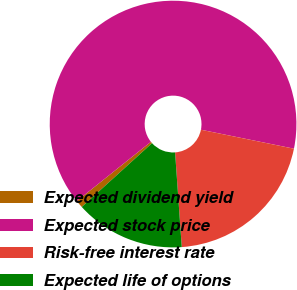Convert chart to OTSL. <chart><loc_0><loc_0><loc_500><loc_500><pie_chart><fcel>Expected dividend yield<fcel>Expected stock price<fcel>Risk-free interest rate<fcel>Expected life of options<nl><fcel>0.99%<fcel>63.94%<fcel>20.68%<fcel>14.39%<nl></chart> 